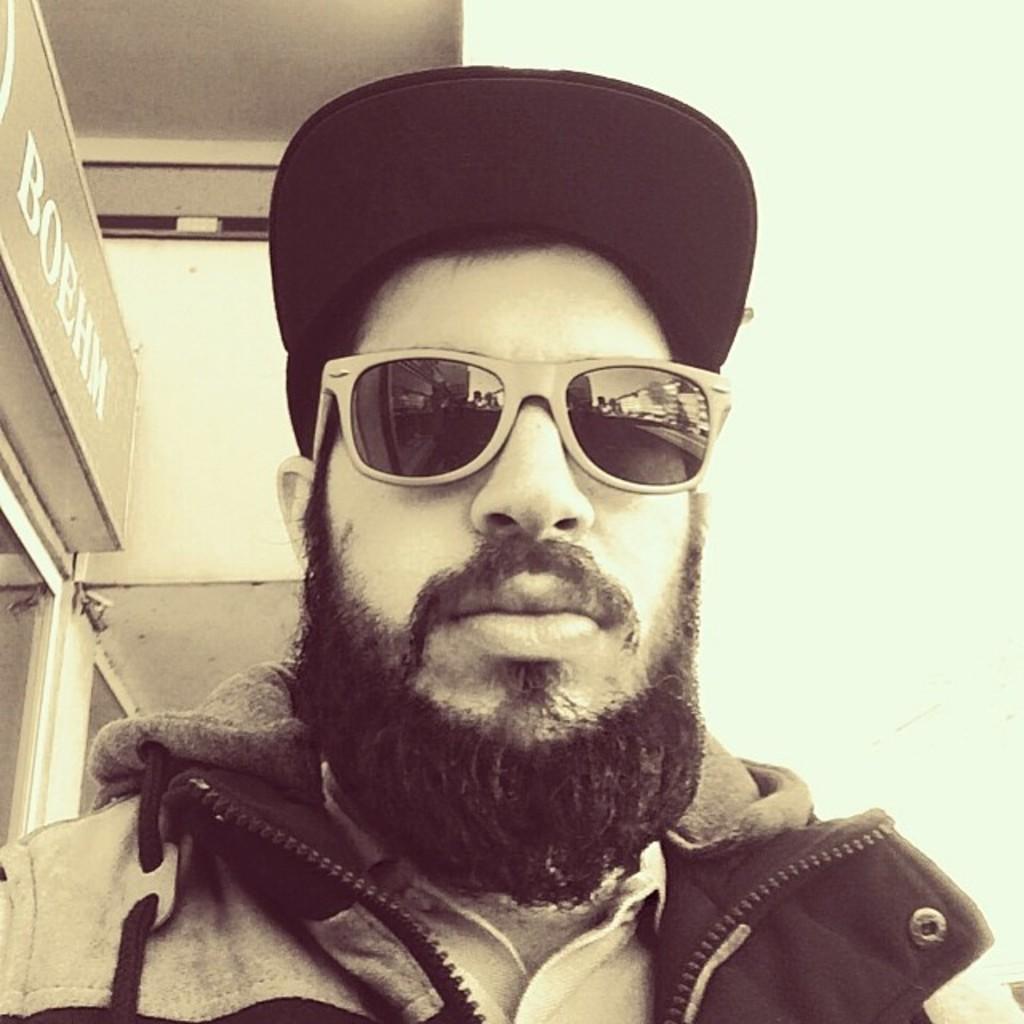Can you describe this image briefly? In the background we can see the wall. On the left side of the picture we can see a board. In this picture we can see a man wearing a cap, jacket and goggles. 